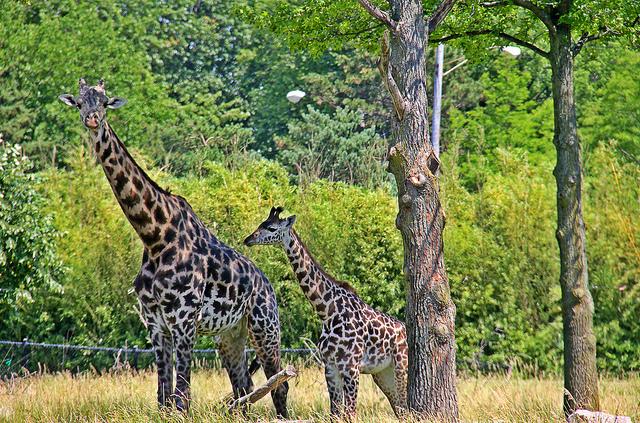Is the bigger giraffe the smaller one's mother?
Give a very brief answer. Yes. Are there lights visible?
Short answer required. Yes. IS the giraffe in a zoo?
Answer briefly. Yes. What animals are in the picture?
Quick response, please. Giraffes. What are the giraffes doing?
Quick response, please. Standing. Is this a baby giraffe?
Keep it brief. Yes. 